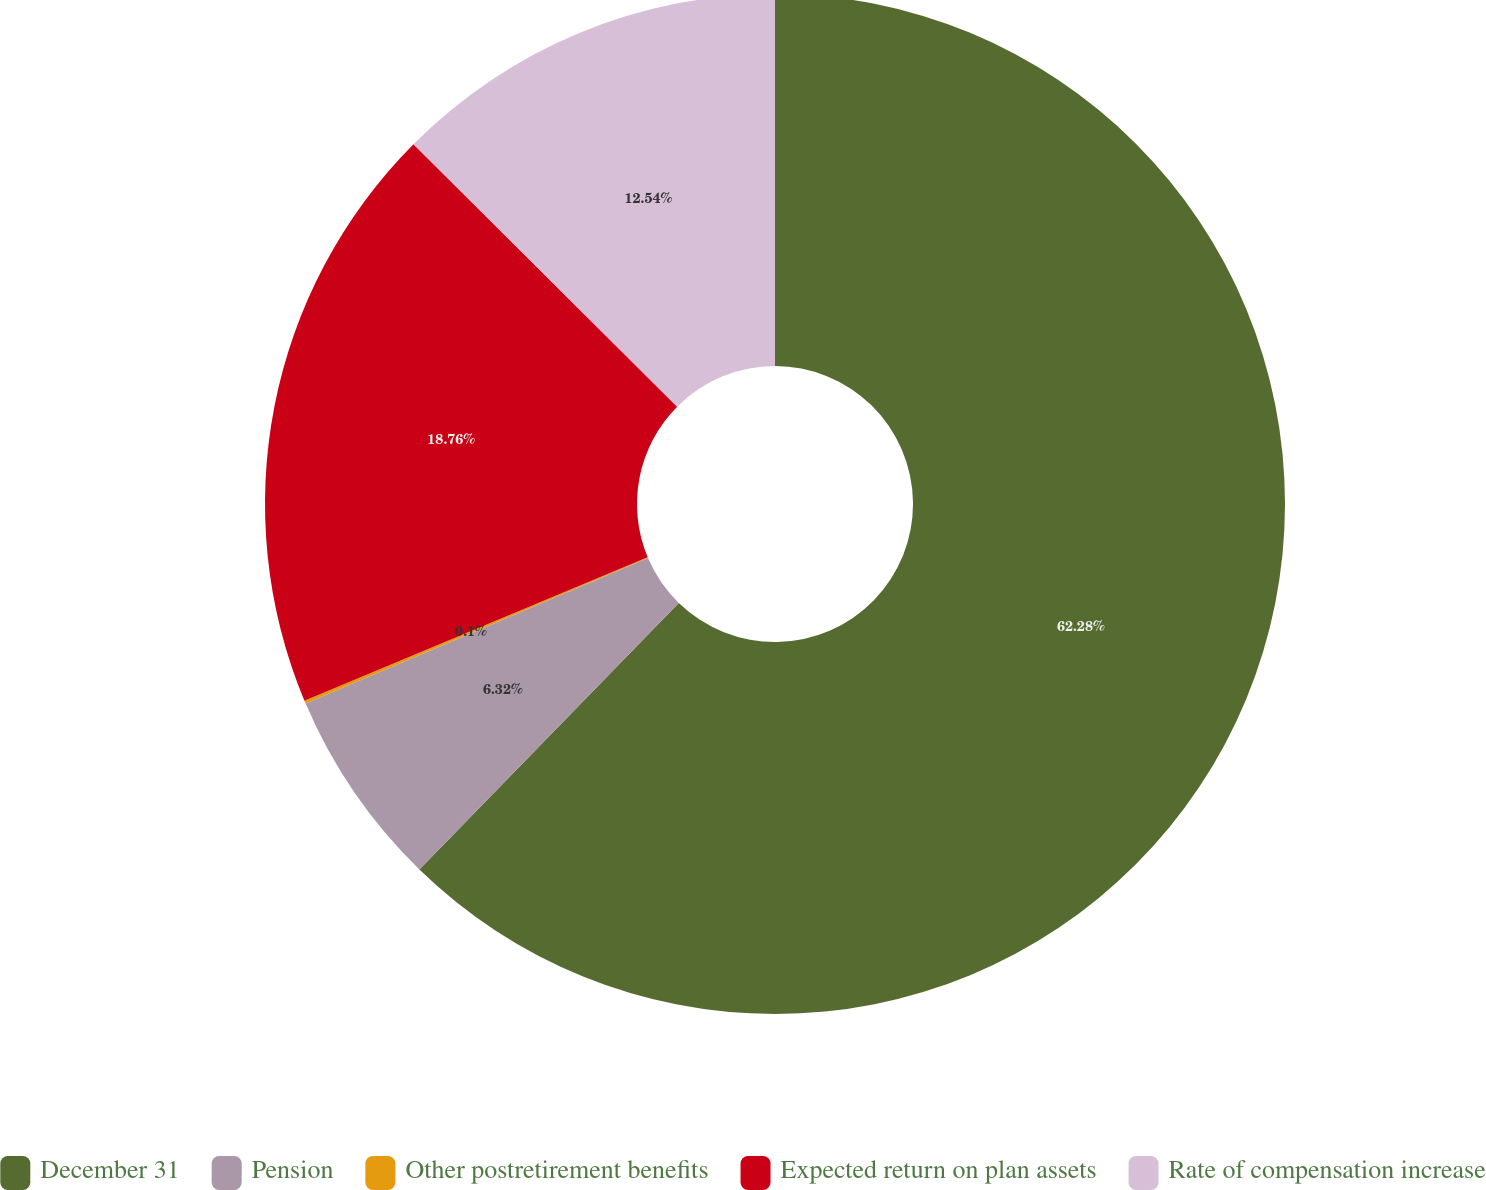Convert chart. <chart><loc_0><loc_0><loc_500><loc_500><pie_chart><fcel>December 31<fcel>Pension<fcel>Other postretirement benefits<fcel>Expected return on plan assets<fcel>Rate of compensation increase<nl><fcel>62.28%<fcel>6.32%<fcel>0.1%<fcel>18.76%<fcel>12.54%<nl></chart> 